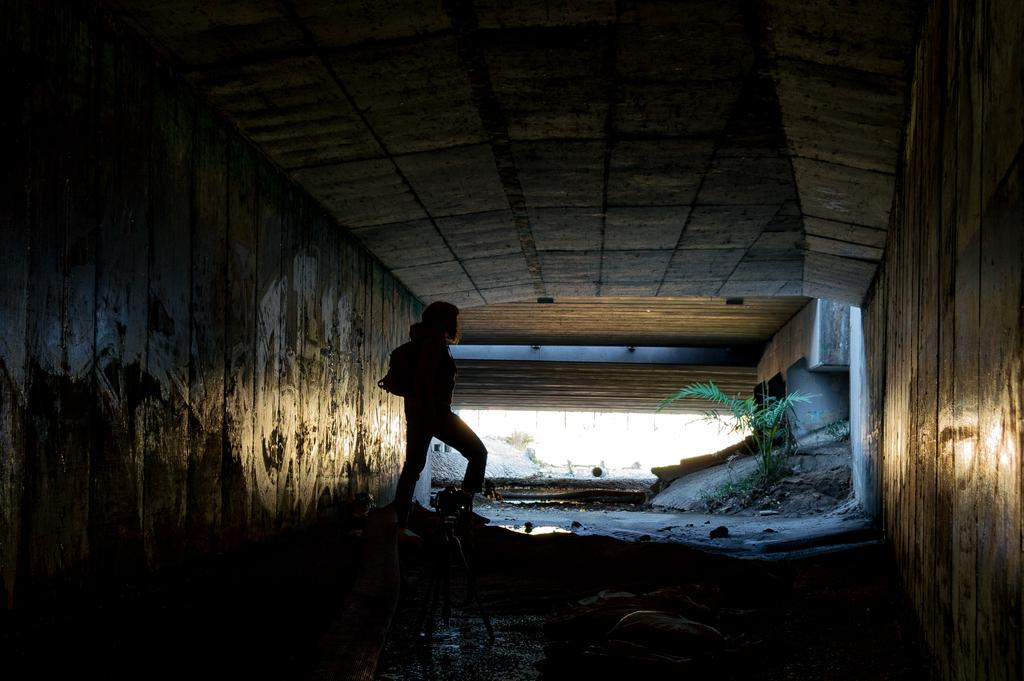What is the main structure in the image? There is a tunnel in the image. What is the woman in the image doing? The woman is carrying a bag in the image. Are there any plants visible in the image? Yes, there is a plant in the image. How are the walls of the tunnel constructed? The tunnel has cement tiles on three sides. What type of sugar can be seen on the plant in the image? There is no sugar present on the plant in the image. Can you hear the bell ringing in the image? There is no bell present in the image. 